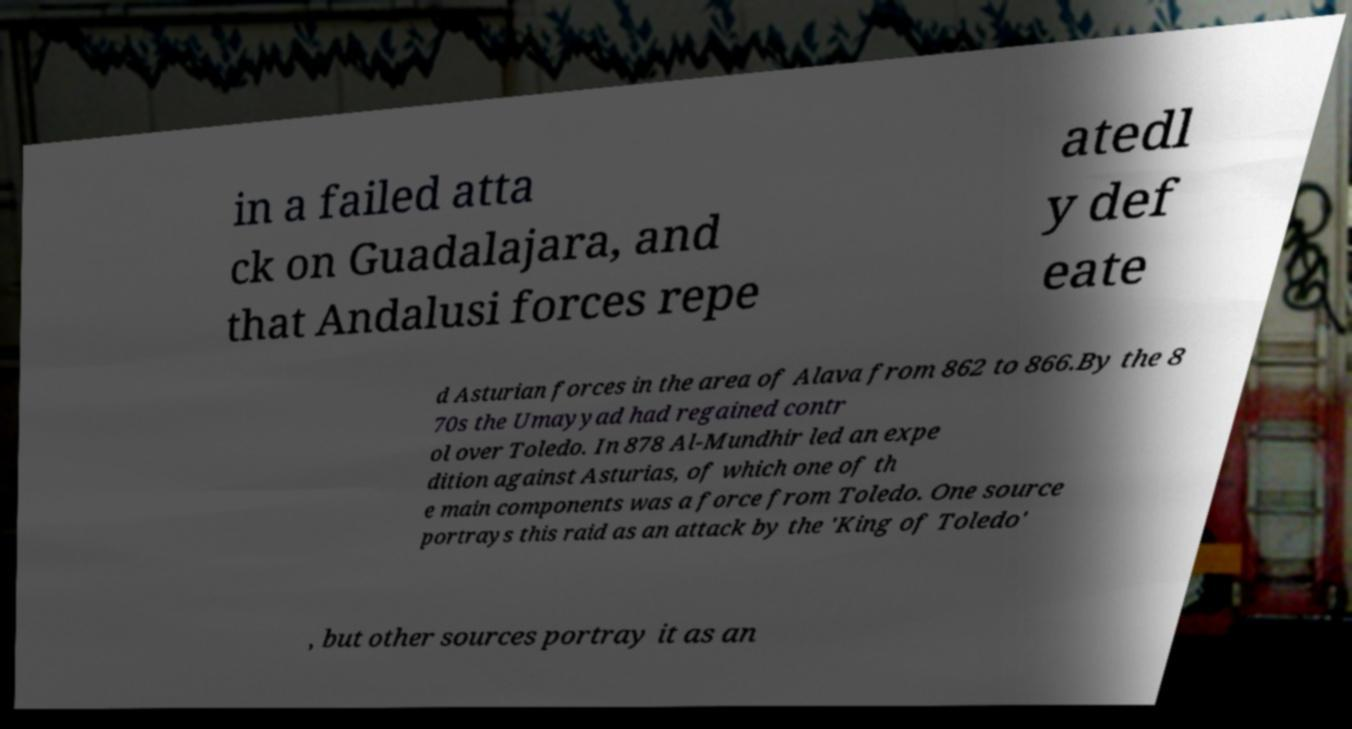Can you accurately transcribe the text from the provided image for me? in a failed atta ck on Guadalajara, and that Andalusi forces repe atedl y def eate d Asturian forces in the area of Alava from 862 to 866.By the 8 70s the Umayyad had regained contr ol over Toledo. In 878 Al-Mundhir led an expe dition against Asturias, of which one of th e main components was a force from Toledo. One source portrays this raid as an attack by the 'King of Toledo' , but other sources portray it as an 